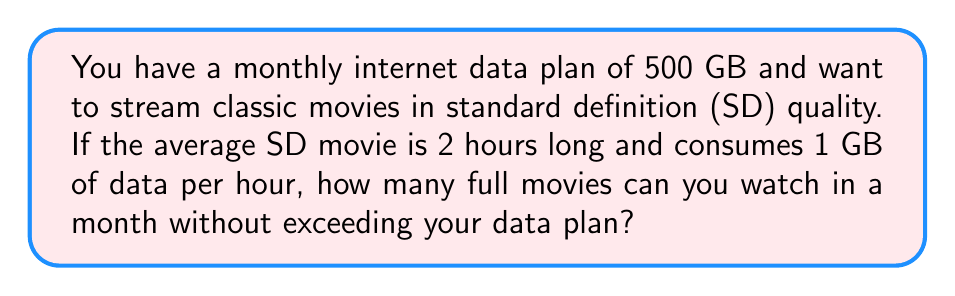Could you help me with this problem? Let's approach this problem step-by-step:

1. Understand the given information:
   * Monthly data plan: 500 GB
   * Average movie length: 2 hours
   * Data consumption rate: 1 GB/hour for SD quality

2. Calculate the data consumption per movie:
   $$ \text{Data per movie} = \text{Movie length} \times \text{Data consumption rate} $$
   $$ \text{Data per movie} = 2 \text{ hours} \times 1 \text{ GB/hour} = 2 \text{ GB} $$

3. Calculate the number of movies that can be streamed:
   $$ \text{Number of movies} = \frac{\text{Total data available}}{\text{Data per movie}} $$
   $$ \text{Number of movies} = \frac{500 \text{ GB}}{2 \text{ GB/movie}} = 250 \text{ movies} $$

Therefore, you can watch 250 full movies in a month without exceeding your data plan.
Answer: 250 movies 